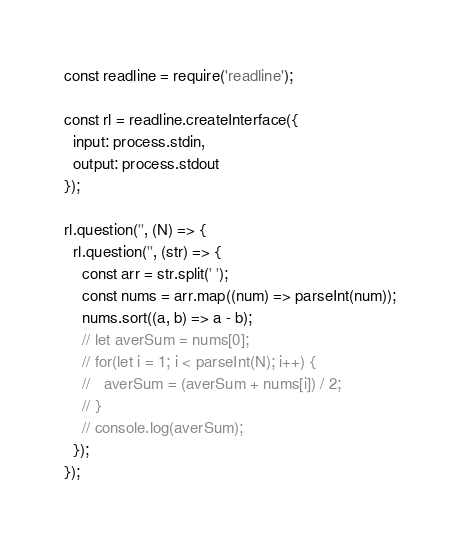<code> <loc_0><loc_0><loc_500><loc_500><_JavaScript_>const readline = require('readline');

const rl = readline.createInterface({
  input: process.stdin,
  output: process.stdout
});

rl.question('', (N) => {
  rl.question('', (str) => {
    const arr = str.split(' ');
    const nums = arr.map((num) => parseInt(num));
    nums.sort((a, b) => a - b);
    // let averSum = nums[0];
    // for(let i = 1; i < parseInt(N); i++) {
    //   averSum = (averSum + nums[i]) / 2;
    // }
    // console.log(averSum);
  });
});</code> 